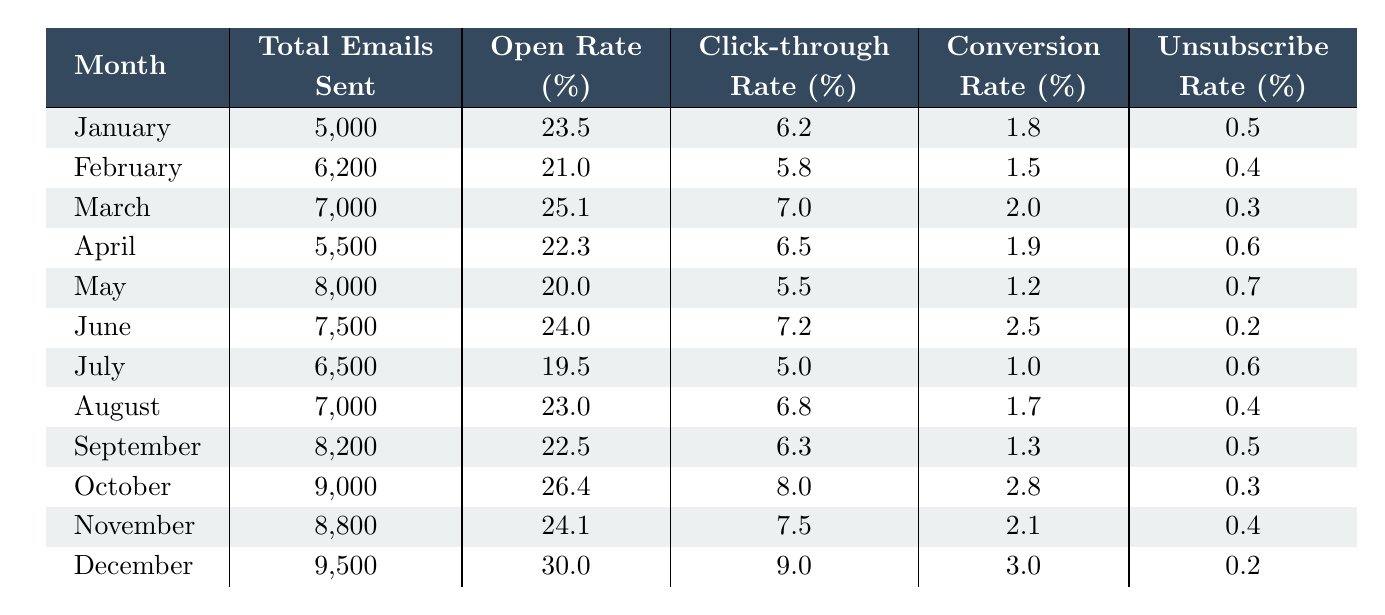What was the total number of emails sent in December? In the table, under the "Total Emails Sent" column for December, the value is 9,500.
Answer: 9,500 What is the Open Rate for March? The Open Rate for March is listed in the table as 25.1%.
Answer: 25.1% Which month had the lowest Click-through Rate? By examining the Click-through Rate column, July has the lowest value at 5.0%.
Answer: 5.0% How many emails were sent in October compared to January? In January, 5,000 emails were sent, and in October, 9,000 emails were sent. The difference is 9,000 - 5,000 = 4,000.
Answer: 4,000 more emails were sent in October What is the average Unsubscribe Rate for the first half of the year (January to June)? The Unsubscribe Rates for January to June are: 0.5, 0.4, 0.3, 0.6, 0.7, and 0.2. Summing these gives 2.7, and dividing by 6 (the number of months) gives an average of 2.7 / 6 = 0.45.
Answer: 0.45 Did the Open Rate increase from February to March? The Open Rate for February is 21.0%, while for March it is 25.1%. Since 25.1% is greater than 21.0%, the Open Rate did increase.
Answer: Yes Which month had a higher Conversion Rate: June or November? June's Conversion Rate is 2.5%, and November's is 2.1%. Since 2.5% is greater than 2.1%, June had a higher rate.
Answer: June What was the average Click-through Rate for the second half of the year (July to December)? The Click-through Rates for July to December are: 5.0, 6.8, 6.3, 8.0, 7.5, and 9.0. Summing these gives 42.6, and dividing by 6 gives an average of 42.6 / 6 = 7.1.
Answer: 7.1 Is the Open Rate in December higher than that in January? January's Open Rate is 23.5%, and December's Open Rate is 30.0%. Since 30.0% > 23.5%, December's rate is higher.
Answer: Yes Which month had the highest Conversion Rate, and what was the percentage? Looking through the table, December has the highest Conversion Rate of 3.0%.
Answer: December, 3.0% How does the total number of emails sent in August compare to the average total emails sent throughout the year? August had 7,000 emails sent. The average total for the year is (5000 + 6200 + 7000 + 5500 + 8000 + 7500 + 6500 + 7000 + 8200 + 9000 + 8800 + 9500) / 12 = 7,360. Since 7,000 is less than 7,360, August’s total is below average.
Answer: Below average 